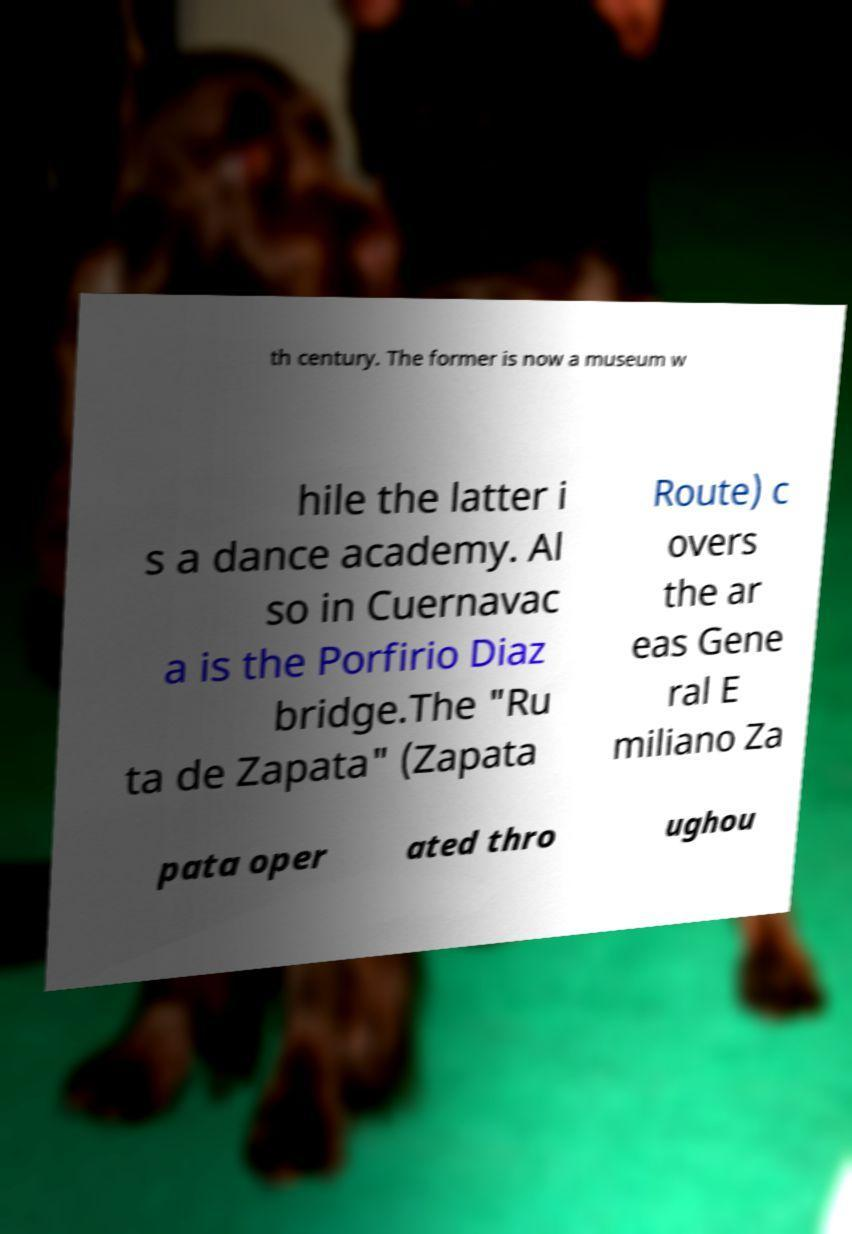What messages or text are displayed in this image? I need them in a readable, typed format. th century. The former is now a museum w hile the latter i s a dance academy. Al so in Cuernavac a is the Porfirio Diaz bridge.The "Ru ta de Zapata" (Zapata Route) c overs the ar eas Gene ral E miliano Za pata oper ated thro ughou 